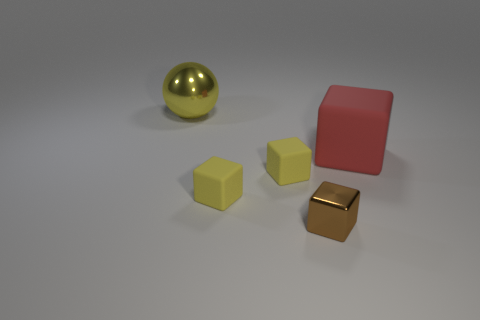There is a large object on the left side of the big thing that is in front of the big yellow object; what is its material?
Your response must be concise. Metal. Are there any other things that are the same size as the shiny block?
Your answer should be very brief. Yes. Does the shiny ball have the same size as the red block?
Make the answer very short. Yes. What number of objects are either objects on the right side of the big yellow sphere or things behind the red rubber cube?
Ensure brevity in your answer.  5. Is the number of small brown shiny cubes behind the brown metal object greater than the number of green objects?
Your answer should be very brief. No. How many other things are the same shape as the tiny metal thing?
Ensure brevity in your answer.  3. How many things are big cubes or small rubber cubes?
Your response must be concise. 3. Is the number of small yellow shiny cylinders greater than the number of small brown metal cubes?
Your response must be concise. No. There is a metal object that is to the right of the big object that is on the left side of the metal block; how big is it?
Offer a terse response. Small. There is another shiny thing that is the same shape as the red object; what is its color?
Your answer should be compact. Brown. 